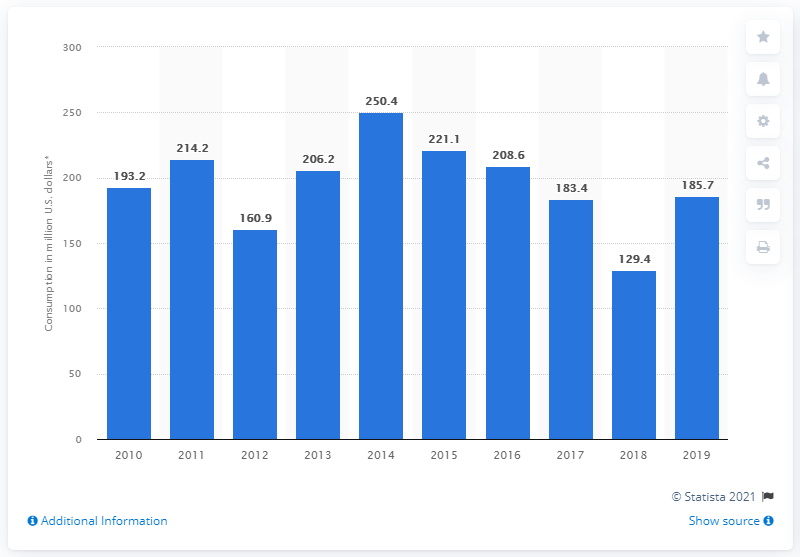Indicate a few pertinent items in this graphic. In the year 2018, Dominica recorded its lowest internal tourism consumption. 